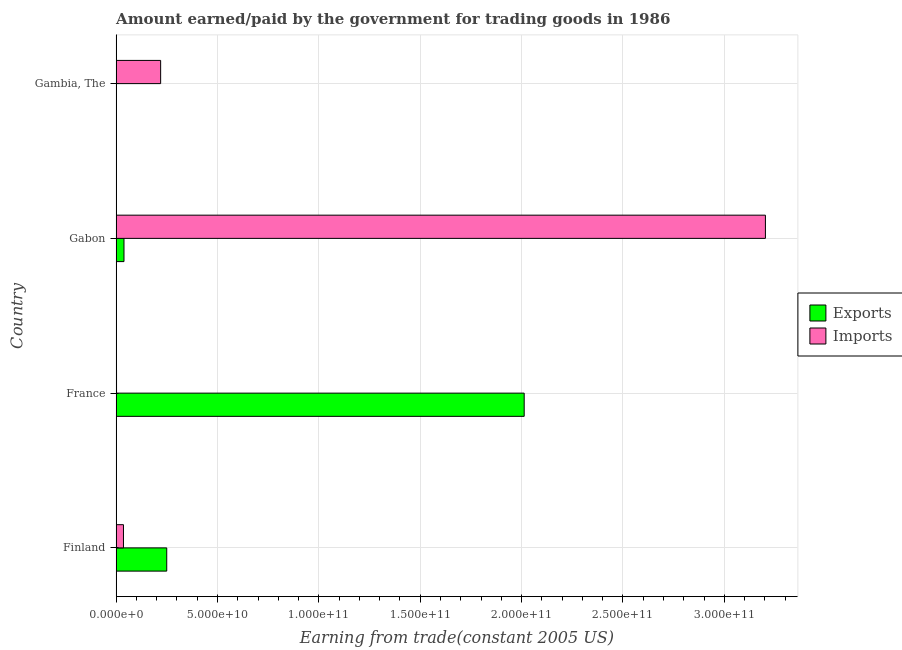How many different coloured bars are there?
Your answer should be compact. 2. Are the number of bars on each tick of the Y-axis equal?
Your response must be concise. Yes. In how many cases, is the number of bars for a given country not equal to the number of legend labels?
Make the answer very short. 0. What is the amount paid for imports in Finland?
Your answer should be very brief. 3.62e+09. Across all countries, what is the maximum amount paid for imports?
Keep it short and to the point. 3.20e+11. Across all countries, what is the minimum amount paid for imports?
Provide a succinct answer. 2.00e+08. In which country was the amount paid for imports minimum?
Provide a short and direct response. France. What is the total amount earned from exports in the graph?
Offer a terse response. 2.30e+11. What is the difference between the amount paid for imports in France and that in Gabon?
Your answer should be very brief. -3.20e+11. What is the difference between the amount paid for imports in Gambia, The and the amount earned from exports in Finland?
Offer a very short reply. -3.00e+09. What is the average amount paid for imports per country?
Offer a very short reply. 8.65e+1. What is the difference between the amount paid for imports and amount earned from exports in Finland?
Your answer should be compact. -2.13e+1. In how many countries, is the amount earned from exports greater than 270000000000 US$?
Your answer should be compact. 0. What is the ratio of the amount paid for imports in Finland to that in Gabon?
Ensure brevity in your answer.  0.01. Is the difference between the amount paid for imports in Finland and France greater than the difference between the amount earned from exports in Finland and France?
Offer a very short reply. Yes. What is the difference between the highest and the second highest amount paid for imports?
Provide a succinct answer. 2.98e+11. What is the difference between the highest and the lowest amount earned from exports?
Provide a succinct answer. 2.01e+11. Is the sum of the amount paid for imports in Finland and France greater than the maximum amount earned from exports across all countries?
Give a very brief answer. No. What does the 1st bar from the top in France represents?
Ensure brevity in your answer.  Imports. What does the 2nd bar from the bottom in Gabon represents?
Make the answer very short. Imports. How many bars are there?
Offer a terse response. 8. Are all the bars in the graph horizontal?
Your response must be concise. Yes. How many countries are there in the graph?
Offer a terse response. 4. What is the difference between two consecutive major ticks on the X-axis?
Keep it short and to the point. 5.00e+1. Are the values on the major ticks of X-axis written in scientific E-notation?
Keep it short and to the point. Yes. Does the graph contain any zero values?
Your answer should be very brief. No. Where does the legend appear in the graph?
Give a very brief answer. Center right. How many legend labels are there?
Offer a terse response. 2. What is the title of the graph?
Offer a very short reply. Amount earned/paid by the government for trading goods in 1986. Does "Constant 2005 US$" appear as one of the legend labels in the graph?
Give a very brief answer. No. What is the label or title of the X-axis?
Provide a succinct answer. Earning from trade(constant 2005 US). What is the label or title of the Y-axis?
Offer a terse response. Country. What is the Earning from trade(constant 2005 US) of Exports in Finland?
Make the answer very short. 2.50e+1. What is the Earning from trade(constant 2005 US) in Imports in Finland?
Give a very brief answer. 3.62e+09. What is the Earning from trade(constant 2005 US) in Exports in France?
Provide a succinct answer. 2.01e+11. What is the Earning from trade(constant 2005 US) in Imports in France?
Offer a very short reply. 2.00e+08. What is the Earning from trade(constant 2005 US) in Exports in Gabon?
Give a very brief answer. 3.87e+09. What is the Earning from trade(constant 2005 US) of Imports in Gabon?
Keep it short and to the point. 3.20e+11. What is the Earning from trade(constant 2005 US) of Exports in Gambia, The?
Offer a very short reply. 1.35e+08. What is the Earning from trade(constant 2005 US) in Imports in Gambia, The?
Make the answer very short. 2.20e+1. Across all countries, what is the maximum Earning from trade(constant 2005 US) of Exports?
Provide a short and direct response. 2.01e+11. Across all countries, what is the maximum Earning from trade(constant 2005 US) of Imports?
Make the answer very short. 3.20e+11. Across all countries, what is the minimum Earning from trade(constant 2005 US) in Exports?
Ensure brevity in your answer.  1.35e+08. Across all countries, what is the minimum Earning from trade(constant 2005 US) in Imports?
Make the answer very short. 2.00e+08. What is the total Earning from trade(constant 2005 US) of Exports in the graph?
Make the answer very short. 2.30e+11. What is the total Earning from trade(constant 2005 US) in Imports in the graph?
Give a very brief answer. 3.46e+11. What is the difference between the Earning from trade(constant 2005 US) of Exports in Finland and that in France?
Keep it short and to the point. -1.76e+11. What is the difference between the Earning from trade(constant 2005 US) of Imports in Finland and that in France?
Ensure brevity in your answer.  3.42e+09. What is the difference between the Earning from trade(constant 2005 US) of Exports in Finland and that in Gabon?
Ensure brevity in your answer.  2.11e+1. What is the difference between the Earning from trade(constant 2005 US) of Imports in Finland and that in Gabon?
Provide a short and direct response. -3.17e+11. What is the difference between the Earning from trade(constant 2005 US) of Exports in Finland and that in Gambia, The?
Your answer should be compact. 2.48e+1. What is the difference between the Earning from trade(constant 2005 US) in Imports in Finland and that in Gambia, The?
Keep it short and to the point. -1.83e+1. What is the difference between the Earning from trade(constant 2005 US) of Exports in France and that in Gabon?
Make the answer very short. 1.97e+11. What is the difference between the Earning from trade(constant 2005 US) in Imports in France and that in Gabon?
Make the answer very short. -3.20e+11. What is the difference between the Earning from trade(constant 2005 US) of Exports in France and that in Gambia, The?
Keep it short and to the point. 2.01e+11. What is the difference between the Earning from trade(constant 2005 US) of Imports in France and that in Gambia, The?
Make the answer very short. -2.18e+1. What is the difference between the Earning from trade(constant 2005 US) in Exports in Gabon and that in Gambia, The?
Make the answer very short. 3.74e+09. What is the difference between the Earning from trade(constant 2005 US) in Imports in Gabon and that in Gambia, The?
Provide a succinct answer. 2.98e+11. What is the difference between the Earning from trade(constant 2005 US) of Exports in Finland and the Earning from trade(constant 2005 US) of Imports in France?
Give a very brief answer. 2.48e+1. What is the difference between the Earning from trade(constant 2005 US) in Exports in Finland and the Earning from trade(constant 2005 US) in Imports in Gabon?
Your response must be concise. -2.95e+11. What is the difference between the Earning from trade(constant 2005 US) in Exports in Finland and the Earning from trade(constant 2005 US) in Imports in Gambia, The?
Offer a terse response. 3.00e+09. What is the difference between the Earning from trade(constant 2005 US) in Exports in France and the Earning from trade(constant 2005 US) in Imports in Gabon?
Your answer should be compact. -1.19e+11. What is the difference between the Earning from trade(constant 2005 US) in Exports in France and the Earning from trade(constant 2005 US) in Imports in Gambia, The?
Offer a terse response. 1.79e+11. What is the difference between the Earning from trade(constant 2005 US) of Exports in Gabon and the Earning from trade(constant 2005 US) of Imports in Gambia, The?
Provide a succinct answer. -1.81e+1. What is the average Earning from trade(constant 2005 US) in Exports per country?
Provide a succinct answer. 5.76e+1. What is the average Earning from trade(constant 2005 US) of Imports per country?
Ensure brevity in your answer.  8.65e+1. What is the difference between the Earning from trade(constant 2005 US) in Exports and Earning from trade(constant 2005 US) in Imports in Finland?
Give a very brief answer. 2.13e+1. What is the difference between the Earning from trade(constant 2005 US) in Exports and Earning from trade(constant 2005 US) in Imports in France?
Keep it short and to the point. 2.01e+11. What is the difference between the Earning from trade(constant 2005 US) in Exports and Earning from trade(constant 2005 US) in Imports in Gabon?
Provide a short and direct response. -3.16e+11. What is the difference between the Earning from trade(constant 2005 US) in Exports and Earning from trade(constant 2005 US) in Imports in Gambia, The?
Your answer should be compact. -2.18e+1. What is the ratio of the Earning from trade(constant 2005 US) of Exports in Finland to that in France?
Provide a succinct answer. 0.12. What is the ratio of the Earning from trade(constant 2005 US) of Imports in Finland to that in France?
Your answer should be compact. 18.05. What is the ratio of the Earning from trade(constant 2005 US) in Exports in Finland to that in Gabon?
Your response must be concise. 6.44. What is the ratio of the Earning from trade(constant 2005 US) in Imports in Finland to that in Gabon?
Your answer should be very brief. 0.01. What is the ratio of the Earning from trade(constant 2005 US) of Exports in Finland to that in Gambia, The?
Provide a short and direct response. 185.54. What is the ratio of the Earning from trade(constant 2005 US) in Imports in Finland to that in Gambia, The?
Give a very brief answer. 0.16. What is the ratio of the Earning from trade(constant 2005 US) of Exports in France to that in Gabon?
Give a very brief answer. 51.95. What is the ratio of the Earning from trade(constant 2005 US) in Imports in France to that in Gabon?
Your answer should be very brief. 0. What is the ratio of the Earning from trade(constant 2005 US) in Exports in France to that in Gambia, The?
Give a very brief answer. 1496.33. What is the ratio of the Earning from trade(constant 2005 US) of Imports in France to that in Gambia, The?
Your response must be concise. 0.01. What is the ratio of the Earning from trade(constant 2005 US) in Exports in Gabon to that in Gambia, The?
Provide a short and direct response. 28.8. What is the ratio of the Earning from trade(constant 2005 US) in Imports in Gabon to that in Gambia, The?
Ensure brevity in your answer.  14.59. What is the difference between the highest and the second highest Earning from trade(constant 2005 US) in Exports?
Make the answer very short. 1.76e+11. What is the difference between the highest and the second highest Earning from trade(constant 2005 US) of Imports?
Give a very brief answer. 2.98e+11. What is the difference between the highest and the lowest Earning from trade(constant 2005 US) of Exports?
Offer a terse response. 2.01e+11. What is the difference between the highest and the lowest Earning from trade(constant 2005 US) of Imports?
Offer a terse response. 3.20e+11. 